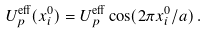Convert formula to latex. <formula><loc_0><loc_0><loc_500><loc_500>U _ { p } ^ { \text {eff} } ( x _ { i } ^ { 0 } ) = U _ { p } ^ { \text {eff} } \cos ( 2 \pi x _ { i } ^ { 0 } / a ) \, .</formula> 